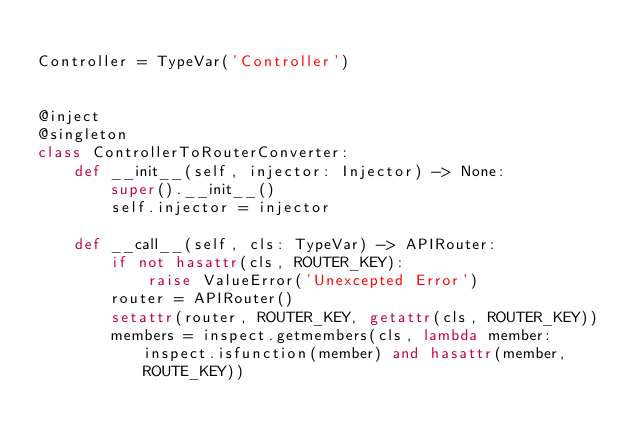<code> <loc_0><loc_0><loc_500><loc_500><_Python_>
Controller = TypeVar('Controller')


@inject
@singleton
class ControllerToRouterConverter:
    def __init__(self, injector: Injector) -> None:
        super().__init__()
        self.injector = injector

    def __call__(self, cls: TypeVar) -> APIRouter:
        if not hasattr(cls, ROUTER_KEY):
            raise ValueError('Unexcepted Error')
        router = APIRouter()
        setattr(router, ROUTER_KEY, getattr(cls, ROUTER_KEY))
        members = inspect.getmembers(cls, lambda member: inspect.isfunction(member) and hasattr(member, ROUTE_KEY))</code> 